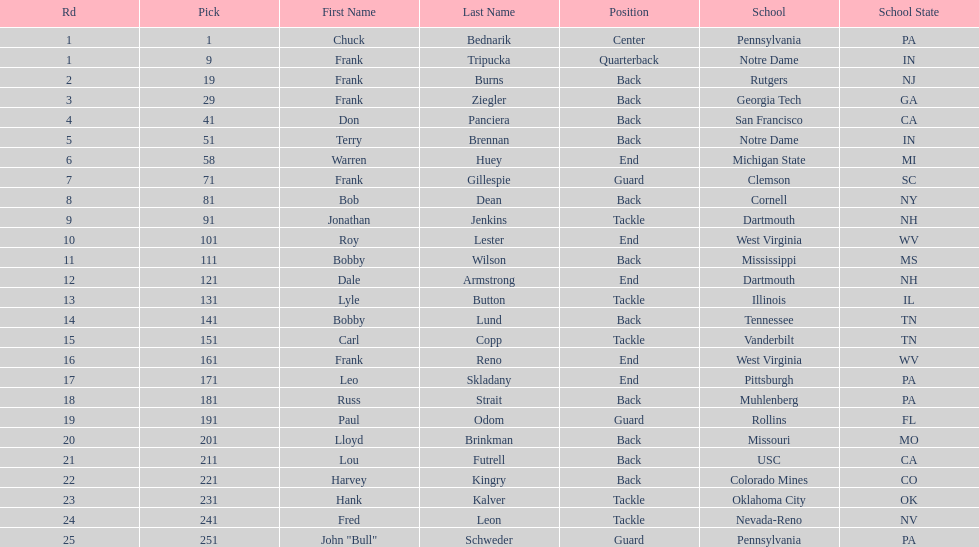Who was picked after frank burns? Frank Ziegler. 